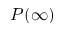<formula> <loc_0><loc_0><loc_500><loc_500>P ( \infty )</formula> 